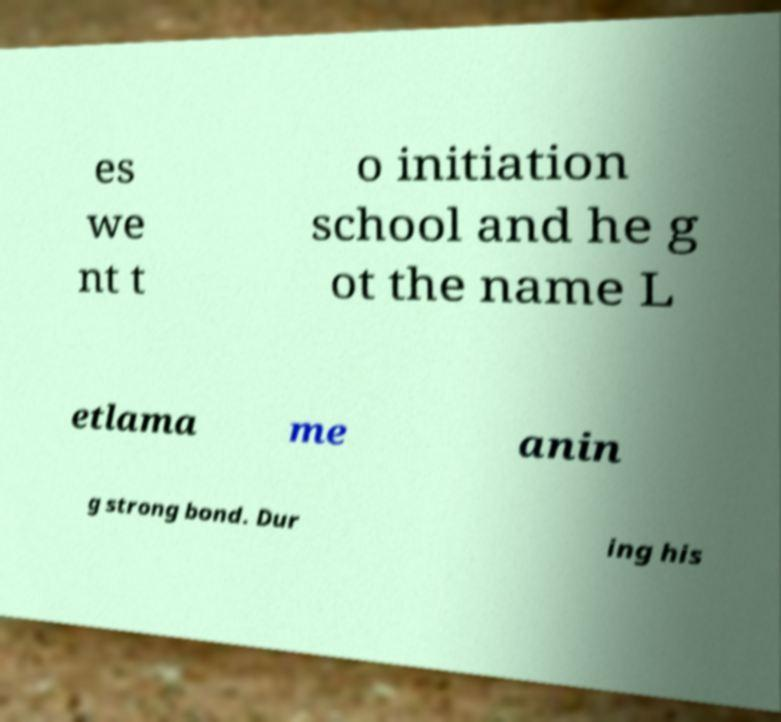Please read and relay the text visible in this image. What does it say? es we nt t o initiation school and he g ot the name L etlama me anin g strong bond. Dur ing his 